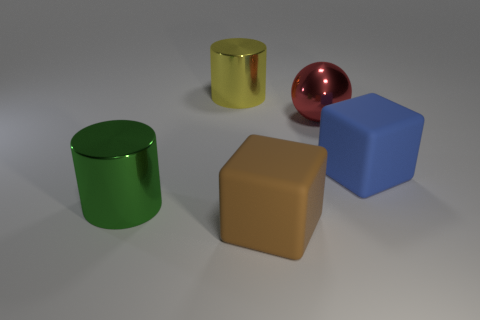Add 5 cylinders. How many objects exist? 10 Subtract all spheres. How many objects are left? 4 Add 5 large shiny cylinders. How many large shiny cylinders exist? 7 Subtract 0 green balls. How many objects are left? 5 Subtract all purple matte cylinders. Subtract all red shiny things. How many objects are left? 4 Add 5 large shiny cylinders. How many large shiny cylinders are left? 7 